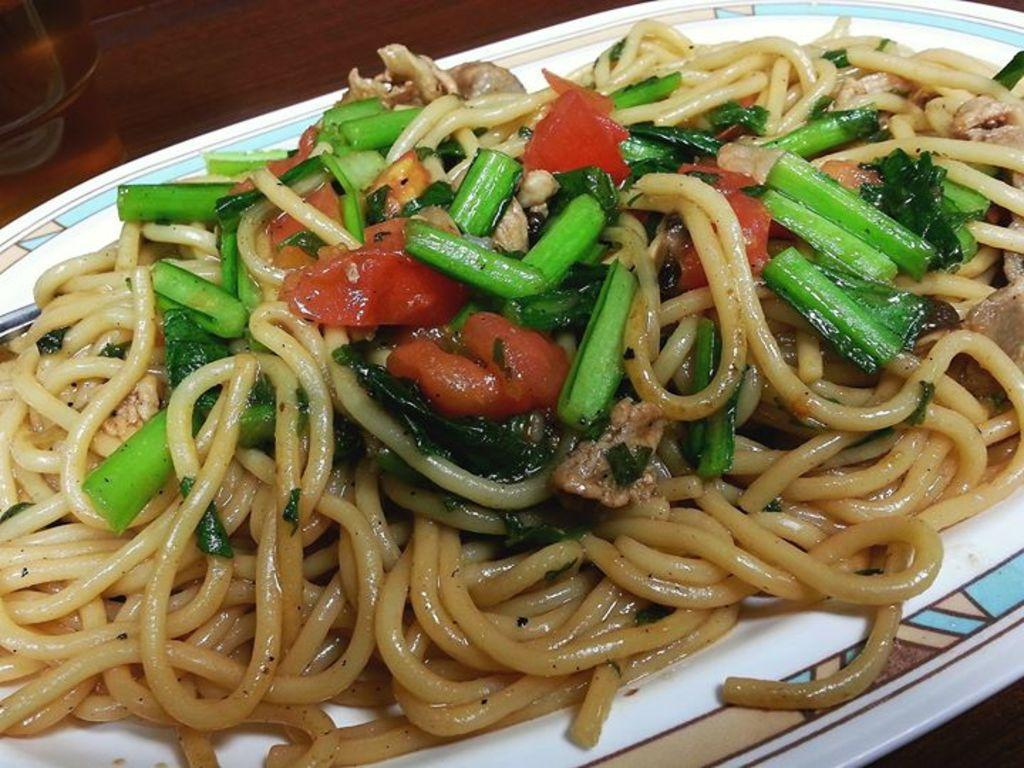What type of food is on the plate in the image? There are noodles on a plate in the image. Are there any other food items on the plate? Yes, there are other food items on the plate. Where is the plate located in the image? The plate is in the center of the image. What can be seen in the top left side of the image? There appears to be a glass in the top left side of the image. What type of bed is visible in the image? There is no bed present in the image; it features a plate of noodles and other food items. 